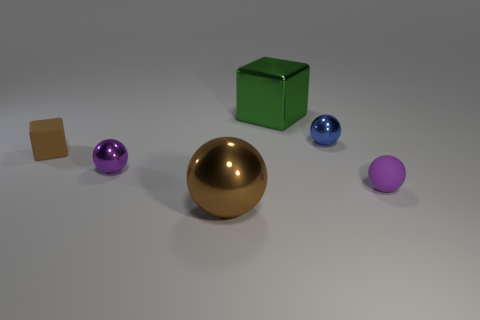How many big things are either cubes or green metallic objects?
Offer a very short reply. 1. Is the color of the big thing in front of the matte cube the same as the small shiny object that is to the left of the large shiny cube?
Offer a terse response. No. How many other things are there of the same color as the tiny block?
Provide a succinct answer. 1. What number of brown things are big metal spheres or rubber balls?
Provide a succinct answer. 1. There is a big green thing; is its shape the same as the object that is in front of the small purple matte object?
Give a very brief answer. No. The large brown object is what shape?
Keep it short and to the point. Sphere. There is a ball that is the same size as the green cube; what is its material?
Your answer should be very brief. Metal. Is there anything else that is the same size as the brown matte thing?
Your response must be concise. Yes. What number of things are rubber balls or shiny objects to the left of the large green shiny cube?
Your response must be concise. 3. What size is the green block that is the same material as the small blue object?
Your answer should be very brief. Large. 